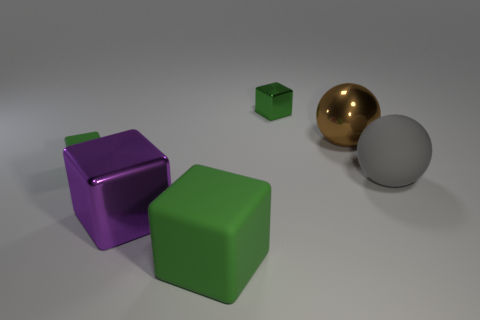Subtract all green balls. How many green blocks are left? 3 Subtract all large rubber blocks. How many blocks are left? 3 Add 3 shiny cubes. How many objects exist? 9 Subtract all purple blocks. How many blocks are left? 3 Subtract all blocks. How many objects are left? 2 Subtract 0 gray blocks. How many objects are left? 6 Subtract all brown blocks. Subtract all gray cylinders. How many blocks are left? 4 Subtract all large purple metal cubes. Subtract all brown shiny things. How many objects are left? 4 Add 5 small green cubes. How many small green cubes are left? 7 Add 2 large red balls. How many large red balls exist? 2 